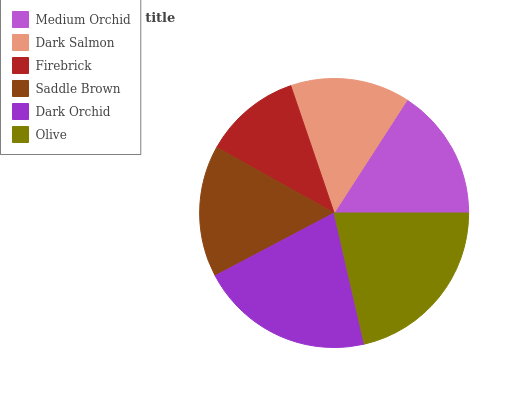Is Firebrick the minimum?
Answer yes or no. Yes. Is Olive the maximum?
Answer yes or no. Yes. Is Dark Salmon the minimum?
Answer yes or no. No. Is Dark Salmon the maximum?
Answer yes or no. No. Is Medium Orchid greater than Dark Salmon?
Answer yes or no. Yes. Is Dark Salmon less than Medium Orchid?
Answer yes or no. Yes. Is Dark Salmon greater than Medium Orchid?
Answer yes or no. No. Is Medium Orchid less than Dark Salmon?
Answer yes or no. No. Is Medium Orchid the high median?
Answer yes or no. Yes. Is Saddle Brown the low median?
Answer yes or no. Yes. Is Dark Orchid the high median?
Answer yes or no. No. Is Olive the low median?
Answer yes or no. No. 